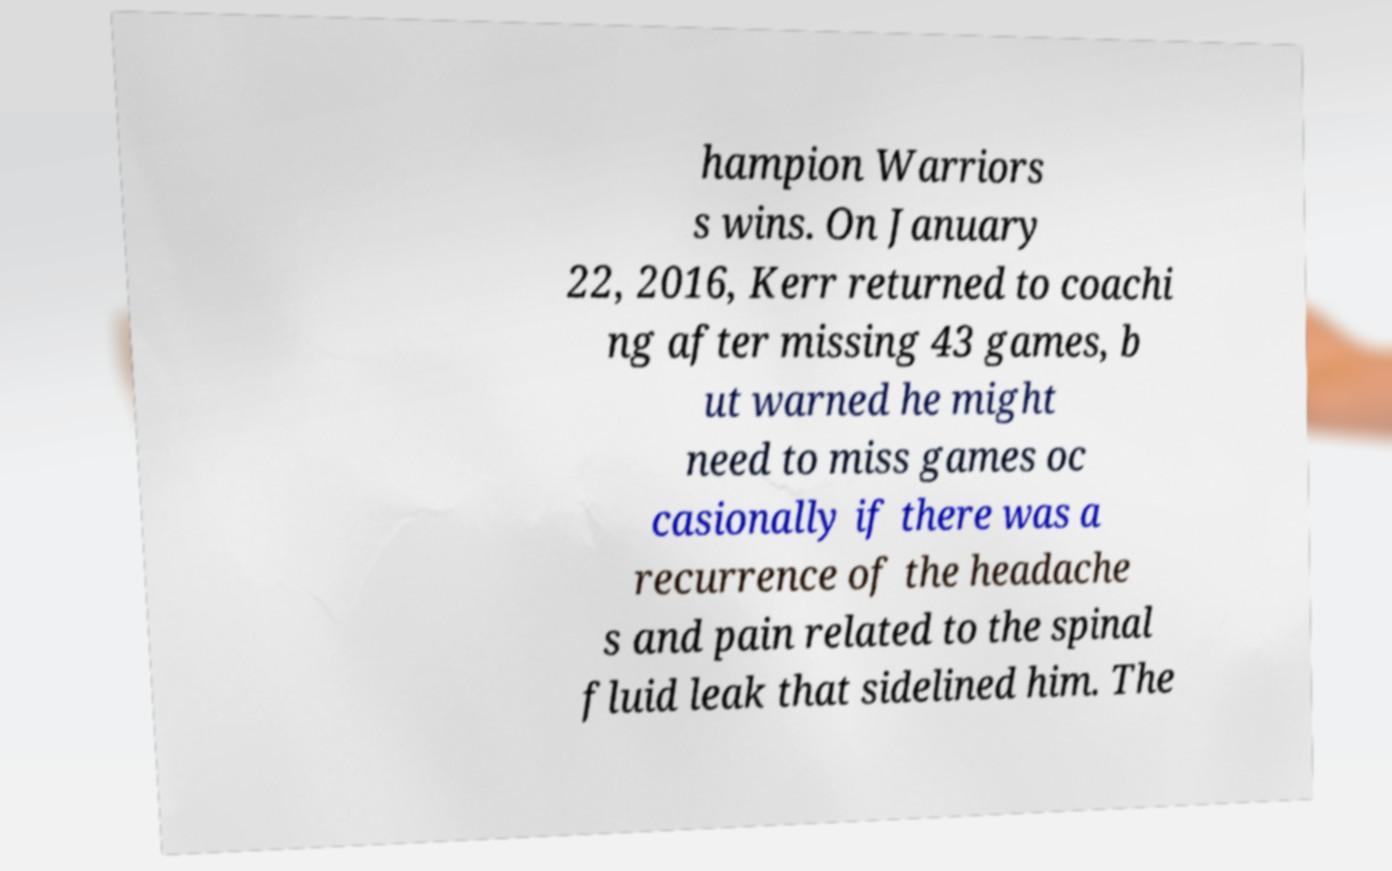Could you extract and type out the text from this image? hampion Warriors s wins. On January 22, 2016, Kerr returned to coachi ng after missing 43 games, b ut warned he might need to miss games oc casionally if there was a recurrence of the headache s and pain related to the spinal fluid leak that sidelined him. The 